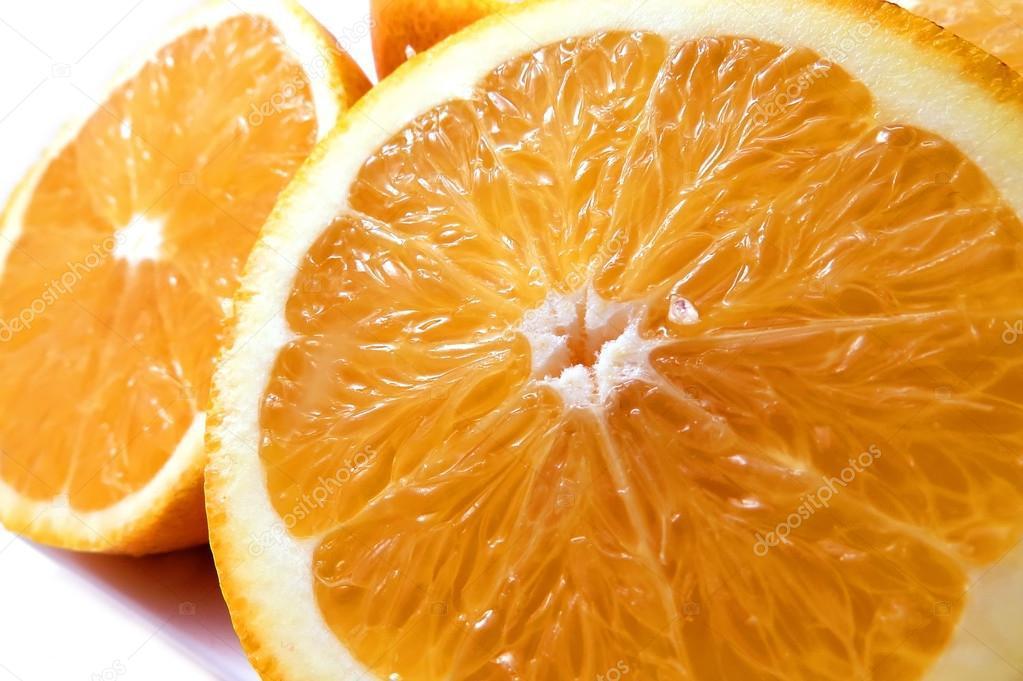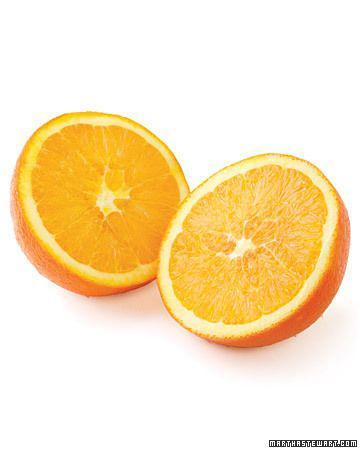The first image is the image on the left, the second image is the image on the right. Analyze the images presented: Is the assertion "One whole orange sits next to half of another orange." valid? Answer yes or no. No. The first image is the image on the left, the second image is the image on the right. For the images shown, is this caption "One image has exactly one and a half oranges." true? Answer yes or no. No. 